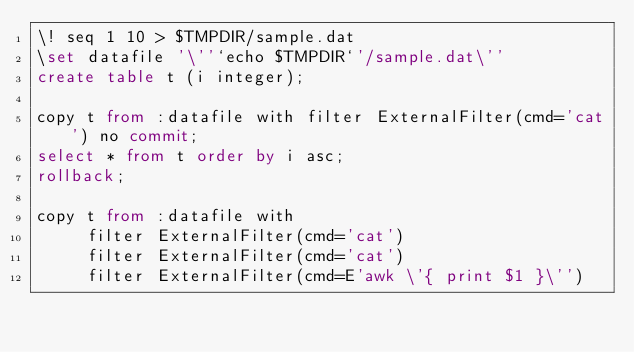Convert code to text. <code><loc_0><loc_0><loc_500><loc_500><_SQL_>\! seq 1 10 > $TMPDIR/sample.dat
\set datafile '\''`echo $TMPDIR`'/sample.dat\''
create table t (i integer);

copy t from :datafile with filter ExternalFilter(cmd='cat') no commit;
select * from t order by i asc;
rollback;

copy t from :datafile with
     filter ExternalFilter(cmd='cat')
     filter ExternalFilter(cmd='cat')
     filter ExternalFilter(cmd=E'awk \'{ print $1 }\'')</code> 